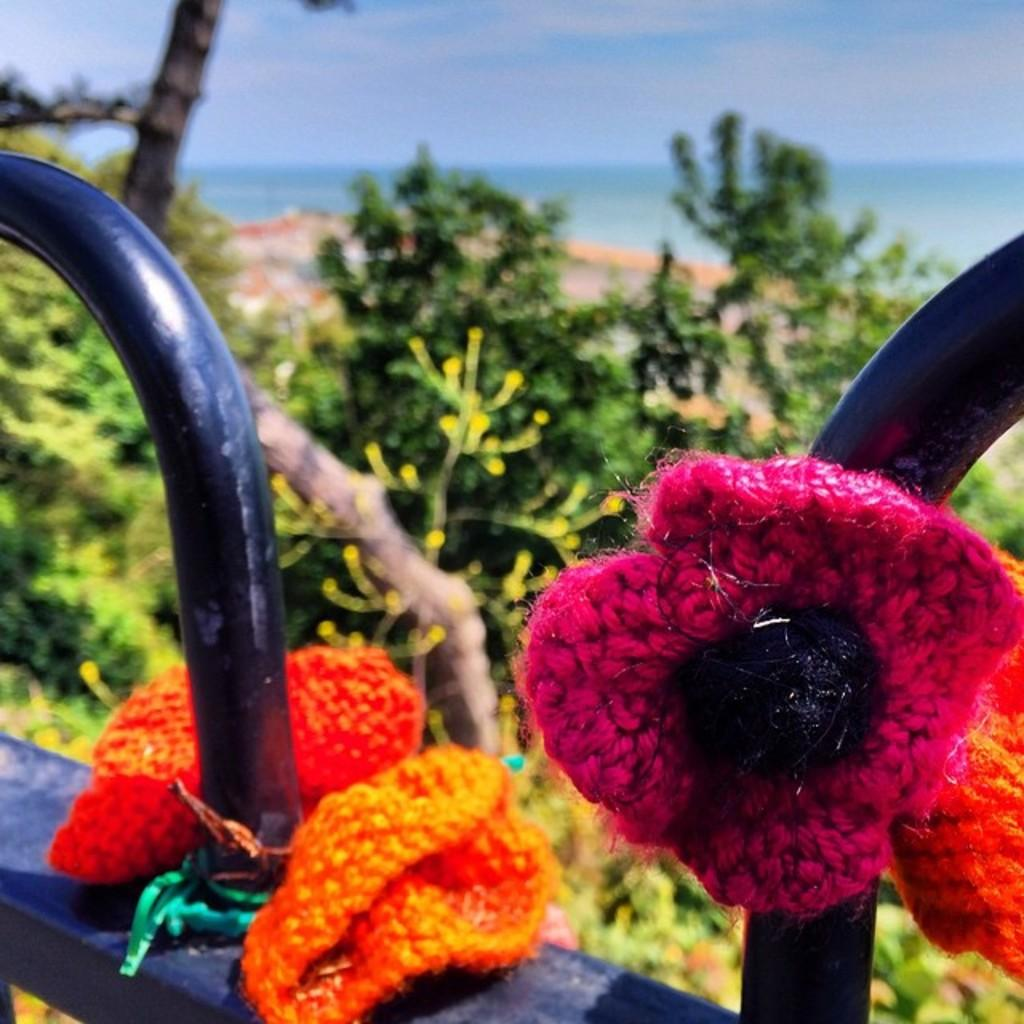What is attached to the iron rods in the image? There are woolen flowers tied to iron rods in the image. What can be seen in the background of the image? There are plants, trees, water, and the sky visible in the background of the image. What shape does the fear take in the image? There is no fear present in the image, so it cannot be given a shape. 